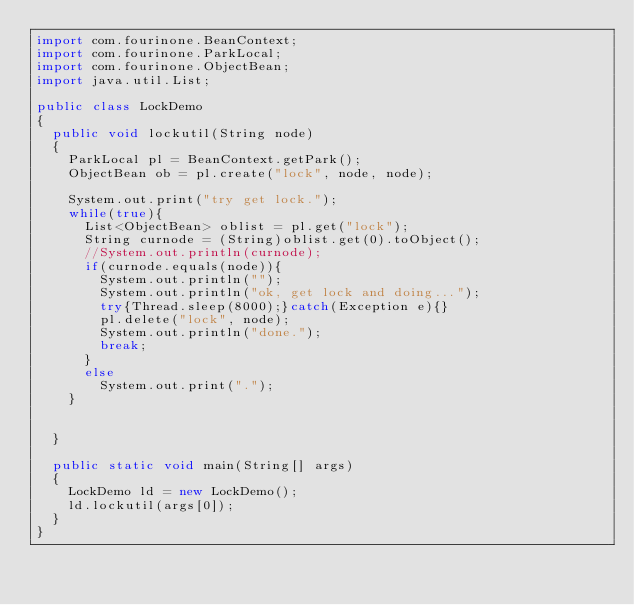<code> <loc_0><loc_0><loc_500><loc_500><_Java_>import com.fourinone.BeanContext;
import com.fourinone.ParkLocal;
import com.fourinone.ObjectBean;
import java.util.List;

public class LockDemo
{
	public void lockutil(String node)
	{
		ParkLocal pl = BeanContext.getPark();
		ObjectBean ob = pl.create("lock", node, node);
		
		System.out.print("try get lock.");
		while(true){
			List<ObjectBean> oblist = pl.get("lock");
			String curnode = (String)oblist.get(0).toObject();
			//System.out.println(curnode);
			if(curnode.equals(node)){
				System.out.println("");
				System.out.println("ok, get lock and doing...");
				try{Thread.sleep(8000);}catch(Exception e){}
				pl.delete("lock", node);
				System.out.println("done.");
				break;
			}
			else
				System.out.print(".");
		}
		
		
	}
	
	public static void main(String[] args)
	{
		LockDemo ld = new LockDemo();
		ld.lockutil(args[0]);
	}
}</code> 